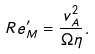<formula> <loc_0><loc_0><loc_500><loc_500>R e _ { M } ^ { \prime } = \frac { v _ { A } ^ { 2 } } { \Omega \eta } .</formula> 